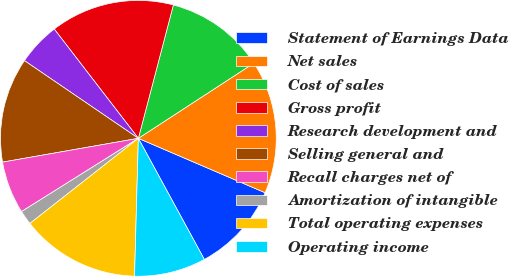Convert chart. <chart><loc_0><loc_0><loc_500><loc_500><pie_chart><fcel>Statement of Earnings Data<fcel>Net sales<fcel>Cost of sales<fcel>Gross profit<fcel>Research development and<fcel>Selling general and<fcel>Recall charges net of<fcel>Amortization of intangible<fcel>Total operating expenses<fcel>Operating income<nl><fcel>10.61%<fcel>15.64%<fcel>11.73%<fcel>14.53%<fcel>5.03%<fcel>12.29%<fcel>6.15%<fcel>1.68%<fcel>13.97%<fcel>8.38%<nl></chart> 